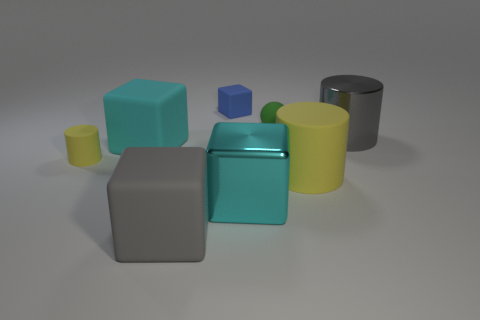Add 2 large gray shiny cylinders. How many objects exist? 10 Subtract all cylinders. How many objects are left? 5 Subtract 0 cyan balls. How many objects are left? 8 Subtract all large gray rubber cubes. Subtract all large yellow cylinders. How many objects are left? 6 Add 8 tiny blue rubber objects. How many tiny blue rubber objects are left? 9 Add 3 tiny gray metallic objects. How many tiny gray metallic objects exist? 3 